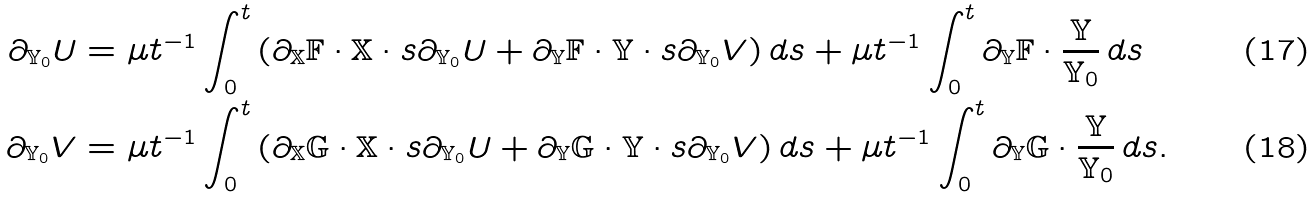Convert formula to latex. <formula><loc_0><loc_0><loc_500><loc_500>\partial _ { { \mathbb { Y } } _ { 0 } } U & = \mu t ^ { - 1 } \int _ { 0 } ^ { t } \left ( \partial _ { \mathbb { X } } { \mathbb { F } } \cdot { \mathbb { X } } \cdot s \partial _ { { \mathbb { Y } } _ { 0 } } U + \partial _ { \mathbb { Y } } { \mathbb { F } } \cdot { \mathbb { Y } } \cdot s \partial _ { { \mathbb { Y } } _ { 0 } } V \right ) d s + \mu t ^ { - 1 } \int _ { 0 } ^ { t } \partial _ { \mathbb { Y } } { \mathbb { F } } \cdot \frac { \mathbb { Y } } { { \mathbb { Y } } _ { 0 } } \, d s \\ \partial _ { { \mathbb { Y } } _ { 0 } } V & = \mu t ^ { - 1 } \int _ { 0 } ^ { t } \left ( \partial _ { \mathbb { X } } { \mathbb { G } } \cdot { \mathbb { X } } \cdot s \partial _ { { \mathbb { Y } } _ { 0 } } U + \partial _ { \mathbb { Y } } { \mathbb { G } } \cdot { \mathbb { Y } } \cdot s \partial _ { { \mathbb { Y } } _ { 0 } } V \right ) d s + \mu t ^ { - 1 } \int _ { 0 } ^ { t } \partial _ { \mathbb { Y } } { \mathbb { G } } \cdot \frac { \mathbb { Y } } { { \mathbb { Y } } _ { 0 } } \, d s .</formula> 